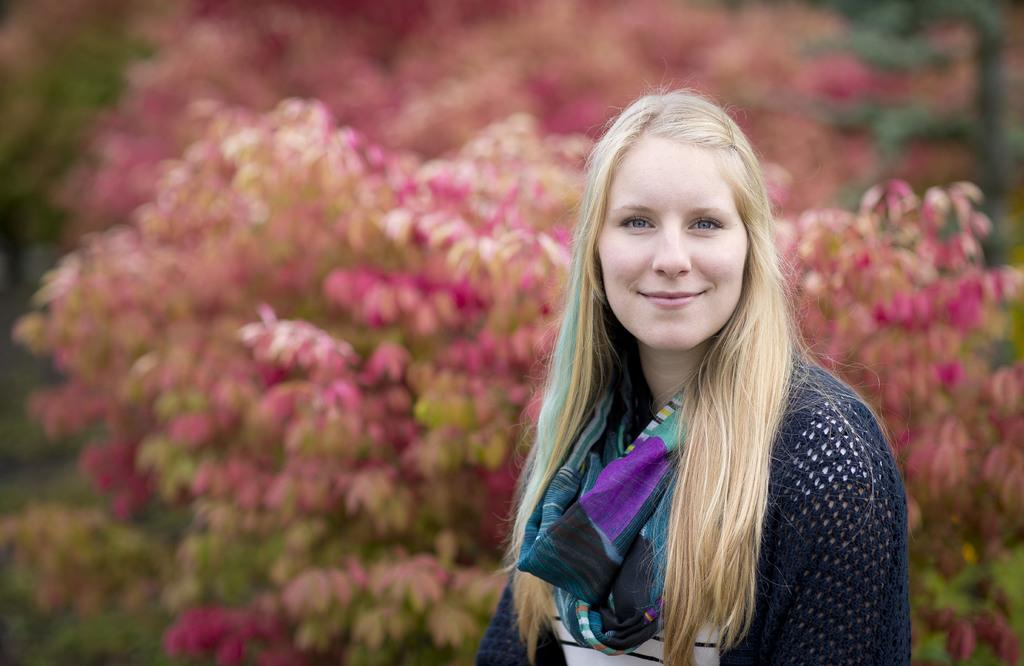Who is present in the image? There is a woman in the image. What expression does the woman have? The woman is smiling. What can be seen in the background of the image? There are flowers in the background of the image. What type of roof can be seen in the image? There is no roof visible in the image. What month is it in the image? The image does not provide information about the month. 